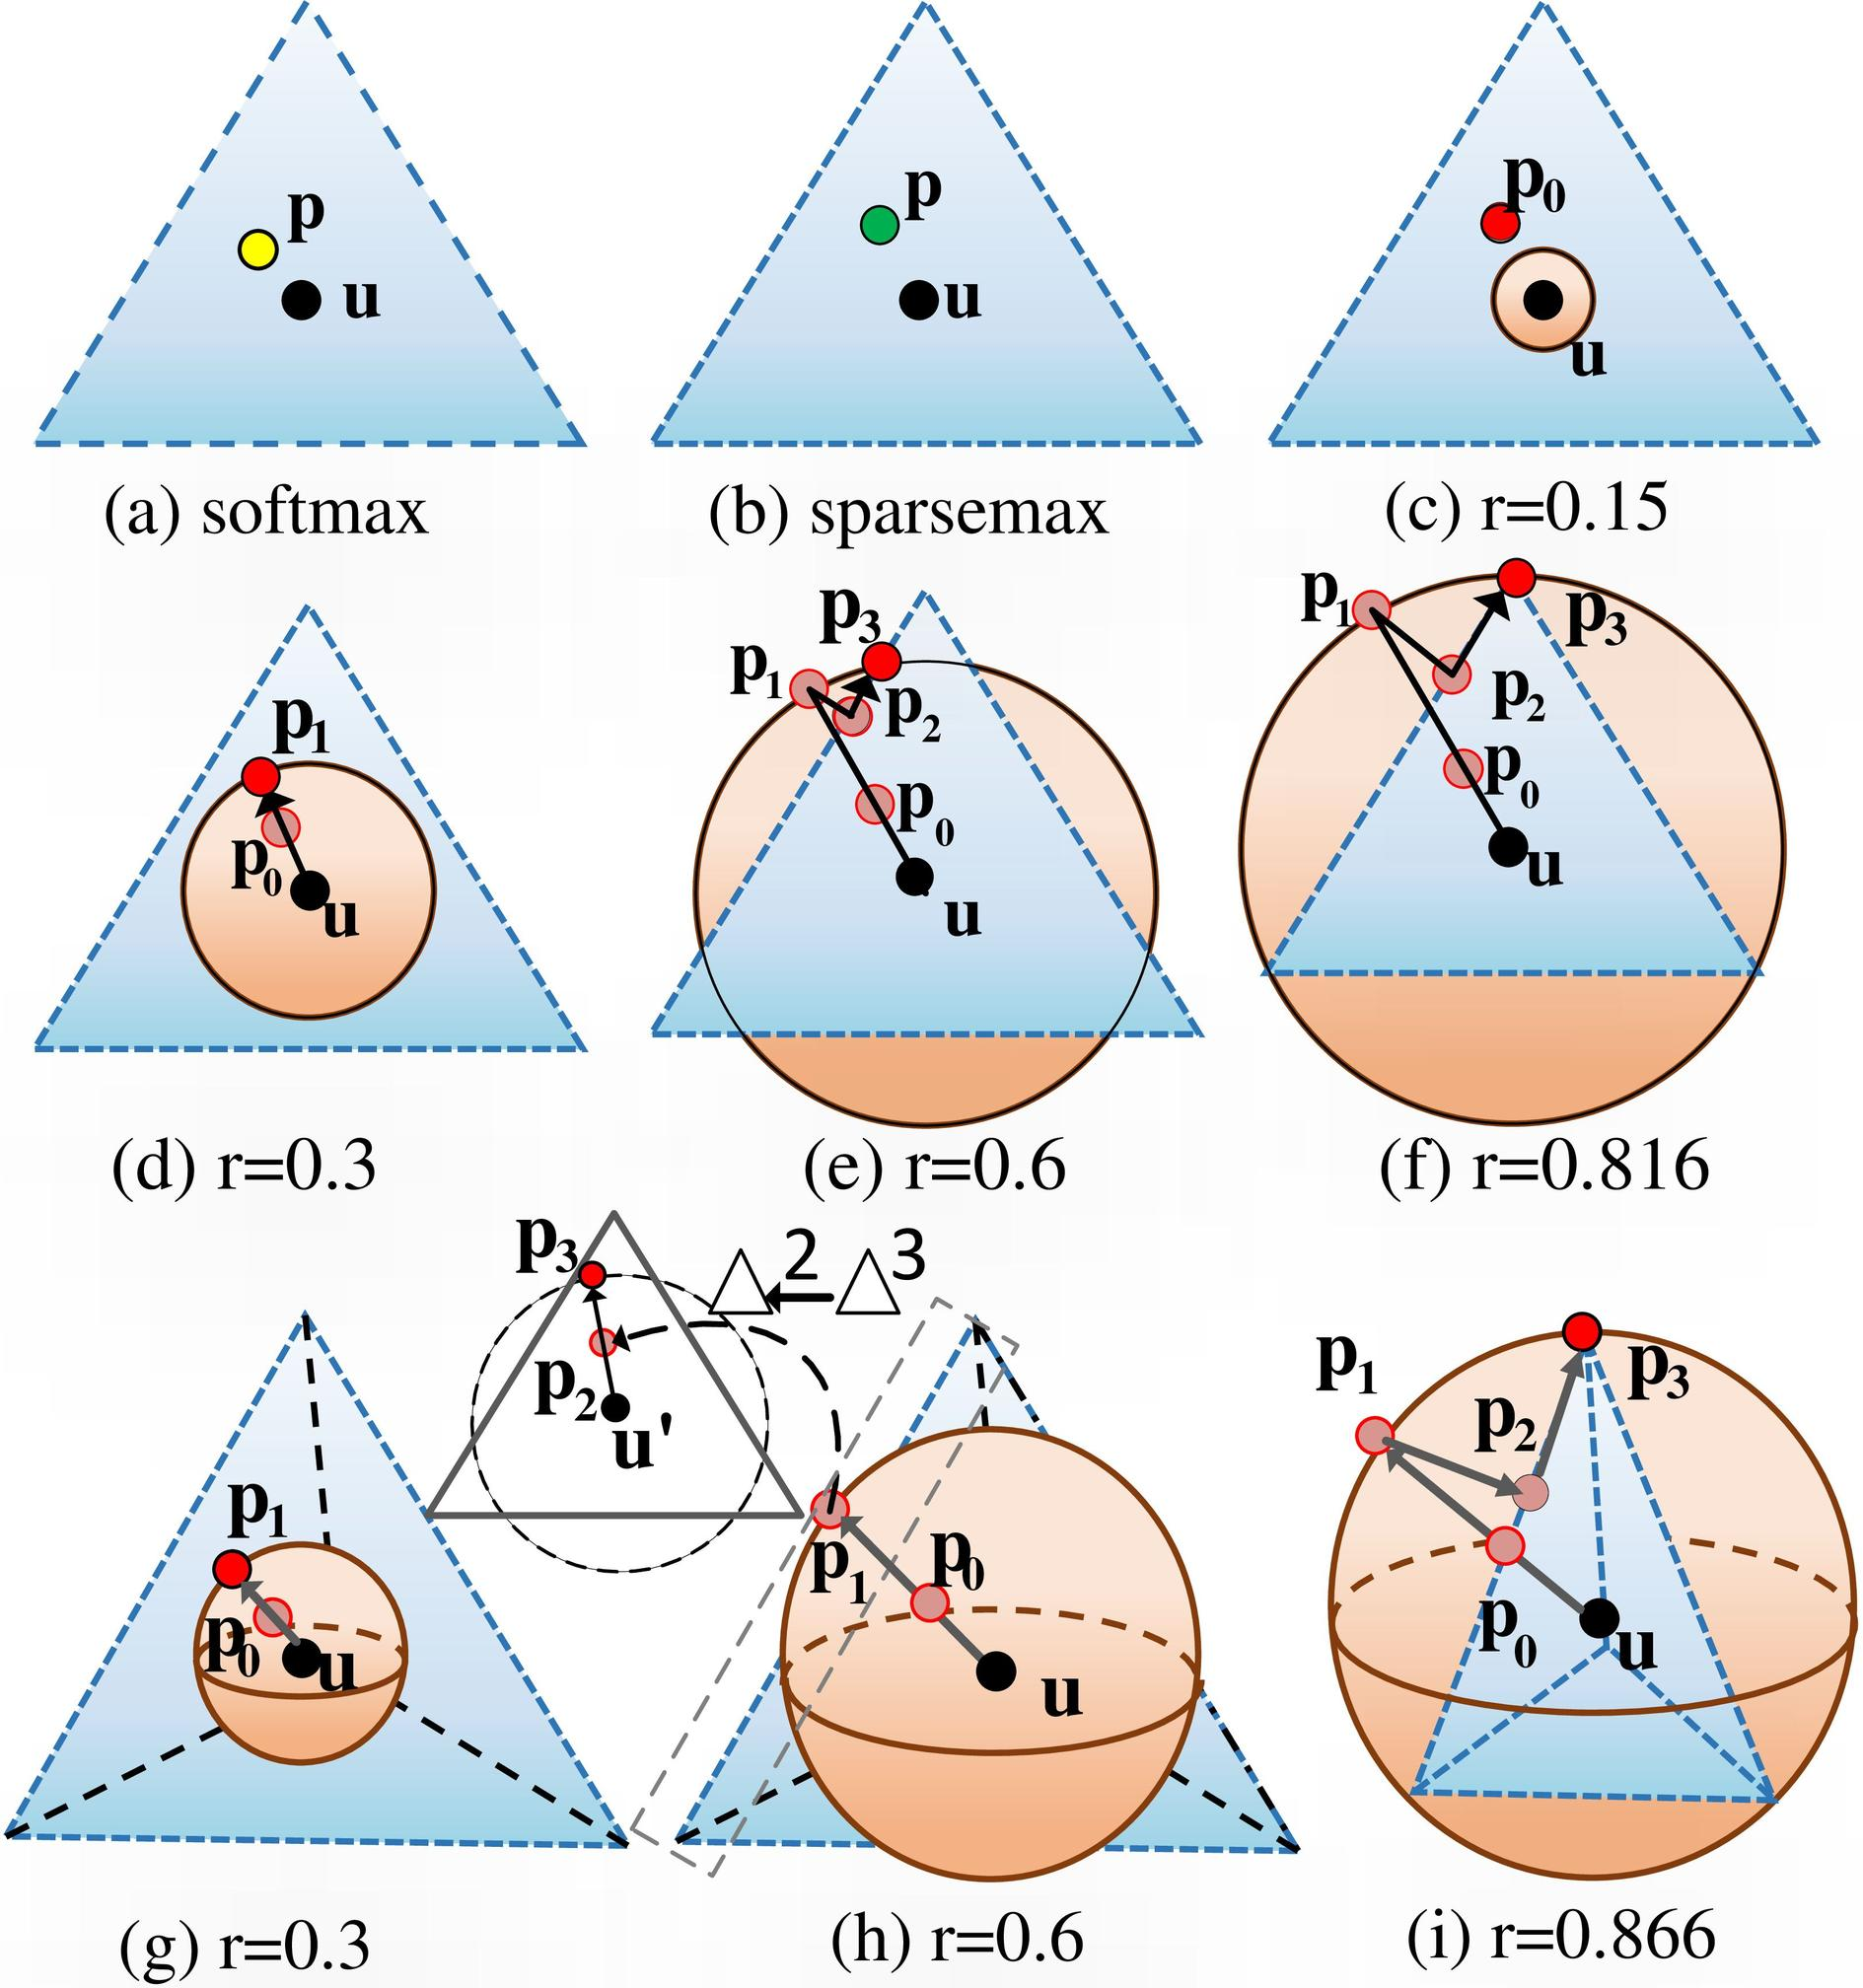What are other contexts where techniques like sparsemax and softmax are applied? Techniques like sparsemax and softmax are widely used in machine learning, especially in classification tasks and natural language processing. Softmax is generally used in multi-class classification to predict probabilities of different classes. Sparsemax, with its ability to produce sparse probabilities, is particularly useful in situations where zero-probable outcomes are preferred, such as in attention mechanisms, where it helps to focus on relevant features only. Can you give an example where sparse probabilities are particularly beneficial? Sure, in natural language processing, sparse probabilities can be beneficial in attention mechanisms within models like Transformers. For example, when processing a sentence, sparsemax can help the model to focus only on the most relevant words or phrases, essentially filtering out less important information. This leads to more efficient processing and often more accurate context understanding and generation of text. 